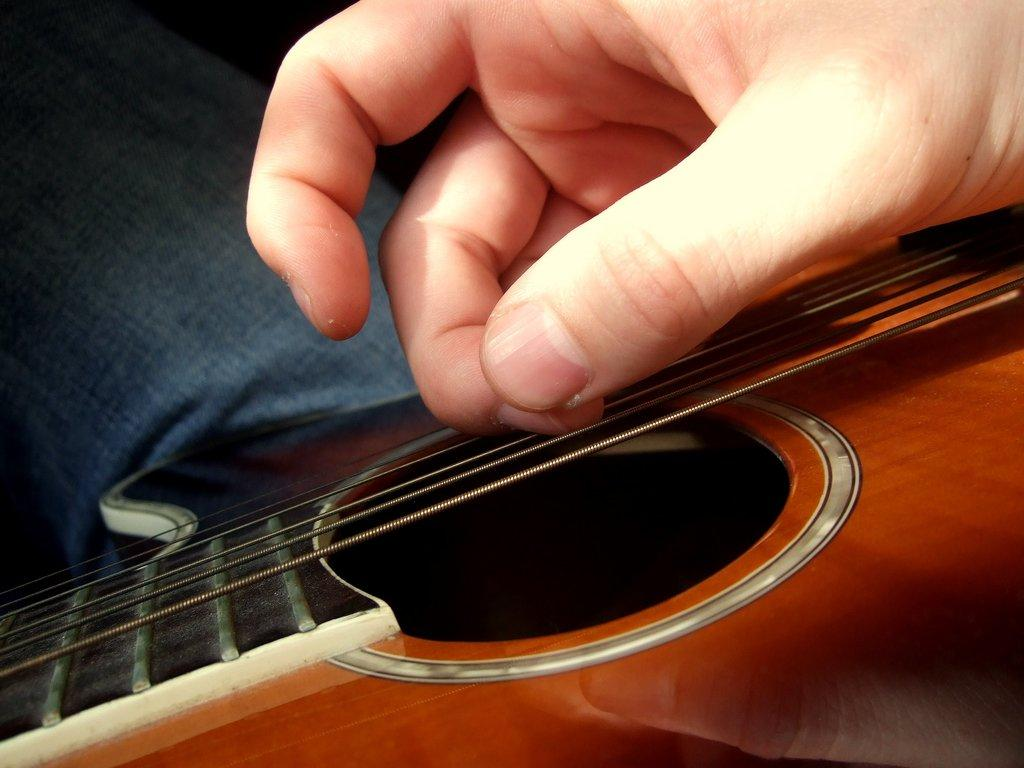What musical instrument is present in the image? There is a guitar in the image. What part of the guitar is being touched in the image? A human hand is placed on the guitar's strings. Can you describe anything visible in the background of the image? There is a leg visible in the background of the image. What type of turkey can be seen smoking a machine in the image? There is no turkey, smoke, or machine present in the image. 